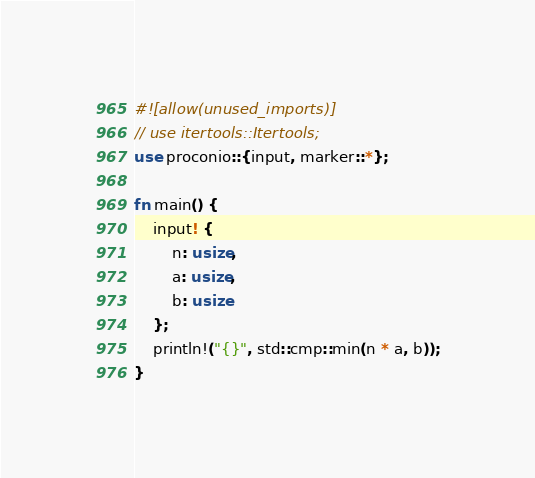<code> <loc_0><loc_0><loc_500><loc_500><_Rust_>#![allow(unused_imports)]
// use itertools::Itertools;
use proconio::{input, marker::*};

fn main() {
    input! {
        n: usize,
        a: usize,
        b: usize
    };
    println!("{}", std::cmp::min(n * a, b));
}
</code> 